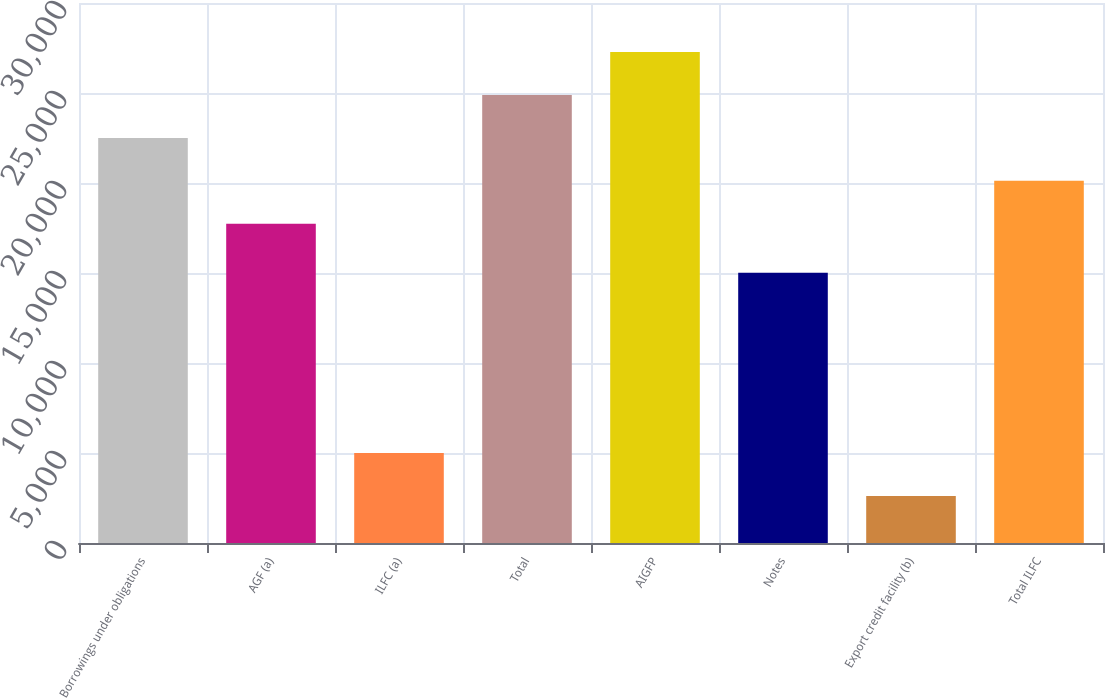Convert chart. <chart><loc_0><loc_0><loc_500><loc_500><bar_chart><fcel>Borrowings under obligations<fcel>AGF (a)<fcel>ILFC (a)<fcel>Total<fcel>AIGFP<fcel>Notes<fcel>Export credit facility (b)<fcel>Total ILFC<nl><fcel>22505.4<fcel>17736<fcel>5000.7<fcel>24890.1<fcel>27274.8<fcel>15011<fcel>2616<fcel>20120.7<nl></chart> 